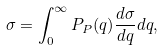<formula> <loc_0><loc_0><loc_500><loc_500>\sigma = \int _ { 0 } ^ { \infty } P _ { P } ( q ) \frac { d \sigma } { d q } d q ,</formula> 